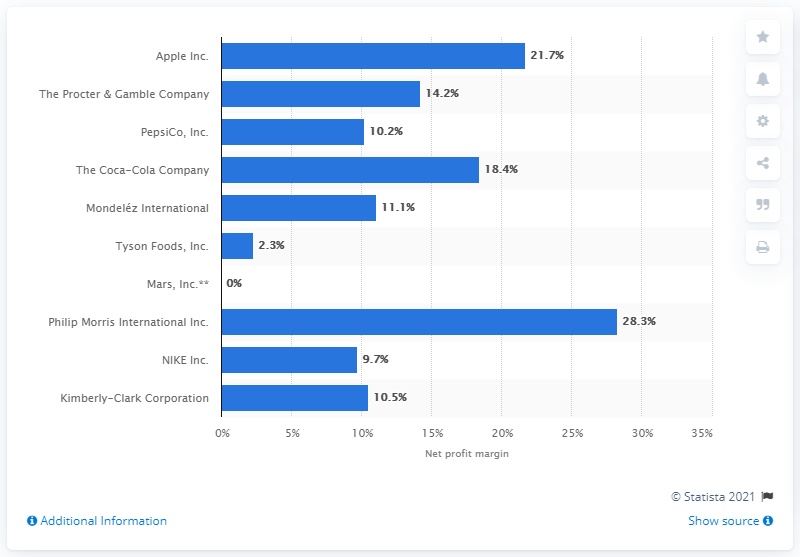Indicate a few pertinent items in this graphic. The net profit margin of Coca-Cola Company in 2013 was 18.4%. 